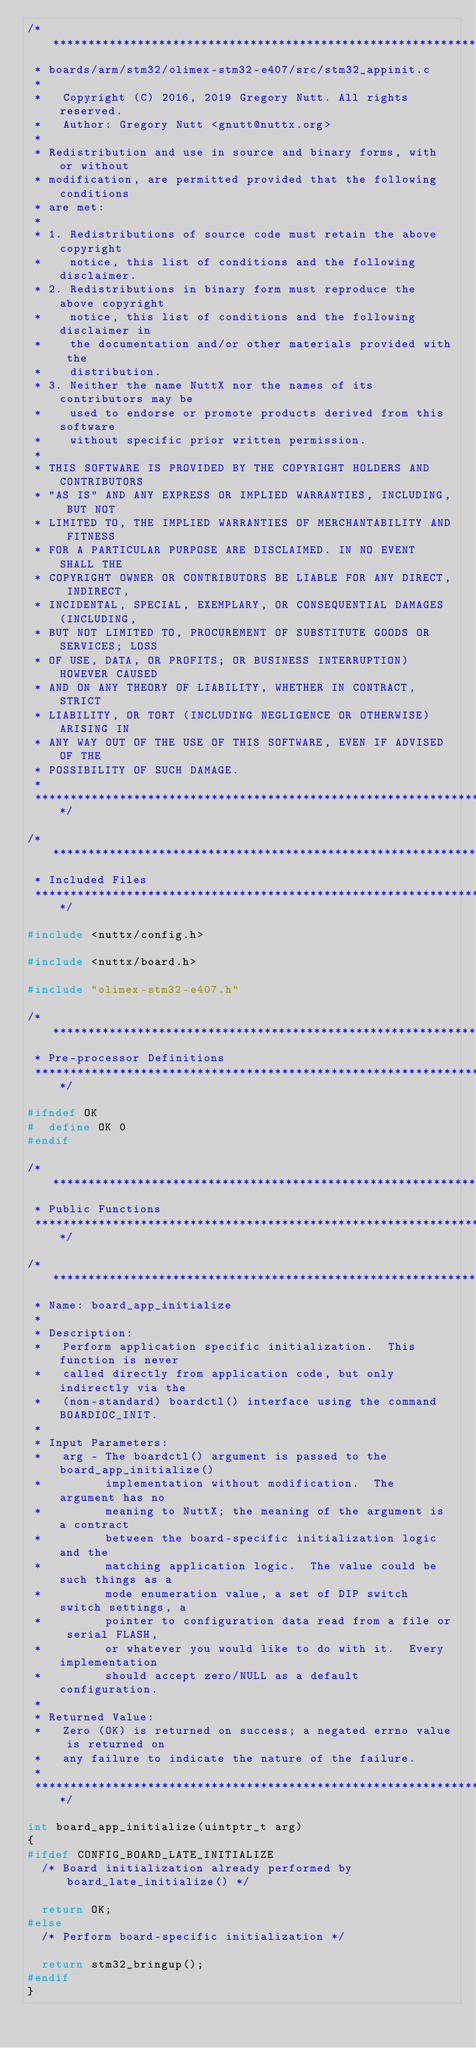Convert code to text. <code><loc_0><loc_0><loc_500><loc_500><_C_>/****************************************************************************
 * boards/arm/stm32/olimex-stm32-e407/src/stm32_appinit.c
 *
 *   Copyright (C) 2016, 2019 Gregory Nutt. All rights reserved.
 *   Author: Gregory Nutt <gnutt@nuttx.org>
 *
 * Redistribution and use in source and binary forms, with or without
 * modification, are permitted provided that the following conditions
 * are met:
 *
 * 1. Redistributions of source code must retain the above copyright
 *    notice, this list of conditions and the following disclaimer.
 * 2. Redistributions in binary form must reproduce the above copyright
 *    notice, this list of conditions and the following disclaimer in
 *    the documentation and/or other materials provided with the
 *    distribution.
 * 3. Neither the name NuttX nor the names of its contributors may be
 *    used to endorse or promote products derived from this software
 *    without specific prior written permission.
 *
 * THIS SOFTWARE IS PROVIDED BY THE COPYRIGHT HOLDERS AND CONTRIBUTORS
 * "AS IS" AND ANY EXPRESS OR IMPLIED WARRANTIES, INCLUDING, BUT NOT
 * LIMITED TO, THE IMPLIED WARRANTIES OF MERCHANTABILITY AND FITNESS
 * FOR A PARTICULAR PURPOSE ARE DISCLAIMED. IN NO EVENT SHALL THE
 * COPYRIGHT OWNER OR CONTRIBUTORS BE LIABLE FOR ANY DIRECT, INDIRECT,
 * INCIDENTAL, SPECIAL, EXEMPLARY, OR CONSEQUENTIAL DAMAGES (INCLUDING,
 * BUT NOT LIMITED TO, PROCUREMENT OF SUBSTITUTE GOODS OR SERVICES; LOSS
 * OF USE, DATA, OR PROFITS; OR BUSINESS INTERRUPTION) HOWEVER CAUSED
 * AND ON ANY THEORY OF LIABILITY, WHETHER IN CONTRACT, STRICT
 * LIABILITY, OR TORT (INCLUDING NEGLIGENCE OR OTHERWISE) ARISING IN
 * ANY WAY OUT OF THE USE OF THIS SOFTWARE, EVEN IF ADVISED OF THE
 * POSSIBILITY OF SUCH DAMAGE.
 *
 ****************************************************************************/

/****************************************************************************
 * Included Files
 ****************************************************************************/

#include <nuttx/config.h>

#include <nuttx/board.h>

#include "olimex-stm32-e407.h"

/****************************************************************************
 * Pre-processor Definitions
 ****************************************************************************/

#ifndef OK
#  define OK 0
#endif

/****************************************************************************
 * Public Functions
 ****************************************************************************/

/****************************************************************************
 * Name: board_app_initialize
 *
 * Description:
 *   Perform application specific initialization.  This function is never
 *   called directly from application code, but only indirectly via the
 *   (non-standard) boardctl() interface using the command BOARDIOC_INIT.
 *
 * Input Parameters:
 *   arg - The boardctl() argument is passed to the board_app_initialize()
 *         implementation without modification.  The argument has no
 *         meaning to NuttX; the meaning of the argument is a contract
 *         between the board-specific initialization logic and the
 *         matching application logic.  The value could be such things as a
 *         mode enumeration value, a set of DIP switch switch settings, a
 *         pointer to configuration data read from a file or serial FLASH,
 *         or whatever you would like to do with it.  Every implementation
 *         should accept zero/NULL as a default configuration.
 *
 * Returned Value:
 *   Zero (OK) is returned on success; a negated errno value is returned on
 *   any failure to indicate the nature of the failure.
 *
 ****************************************************************************/

int board_app_initialize(uintptr_t arg)
{
#ifdef CONFIG_BOARD_LATE_INITIALIZE
  /* Board initialization already performed by board_late_initialize() */

  return OK;
#else
  /* Perform board-specific initialization */

  return stm32_bringup();
#endif
}
</code> 